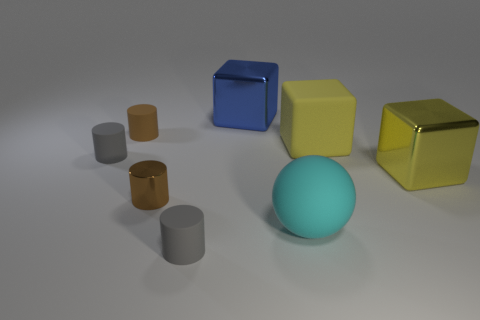What number of other big metallic objects have the same shape as the large yellow shiny thing?
Your answer should be compact. 1. How big is the gray cylinder in front of the big matte object that is in front of the large shiny cube that is right of the large blue object?
Provide a succinct answer. Small. What number of blue objects are either big rubber balls or small metal objects?
Provide a succinct answer. 0. Does the object in front of the big cyan rubber object have the same shape as the brown shiny thing?
Your answer should be very brief. Yes. Are there more shiny objects that are in front of the blue cube than yellow balls?
Offer a very short reply. Yes. What number of brown shiny things are the same size as the brown matte cylinder?
Your answer should be compact. 1. There is a rubber cylinder that is the same color as the small metallic object; what is its size?
Your response must be concise. Small. What number of things are brown metal things or big shiny things that are on the left side of the big cyan matte sphere?
Make the answer very short. 2. The rubber thing that is left of the cyan sphere and in front of the metallic cylinder is what color?
Provide a short and direct response. Gray. Is the size of the blue object the same as the matte block?
Provide a succinct answer. Yes. 